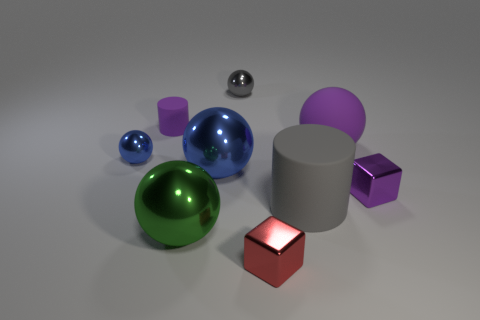What is the large gray cylinder made of?
Ensure brevity in your answer.  Rubber. There is a cylinder to the left of the red metallic cube; does it have the same size as the big purple rubber object?
Ensure brevity in your answer.  No. There is a shiny ball in front of the large matte cylinder; what is its size?
Your response must be concise. Large. How many red metallic blocks are there?
Give a very brief answer. 1. Is the color of the matte ball the same as the tiny matte cylinder?
Your answer should be compact. Yes. There is a large thing that is both on the left side of the red metallic cube and behind the green thing; what is its color?
Give a very brief answer. Blue. There is a small purple cylinder; are there any rubber cylinders in front of it?
Offer a very short reply. Yes. There is a purple shiny block that is behind the small red block; how many small blocks are in front of it?
Give a very brief answer. 1. There is a green ball that is made of the same material as the red block; what size is it?
Provide a short and direct response. Large. What is the size of the green metal object?
Offer a terse response. Large. 